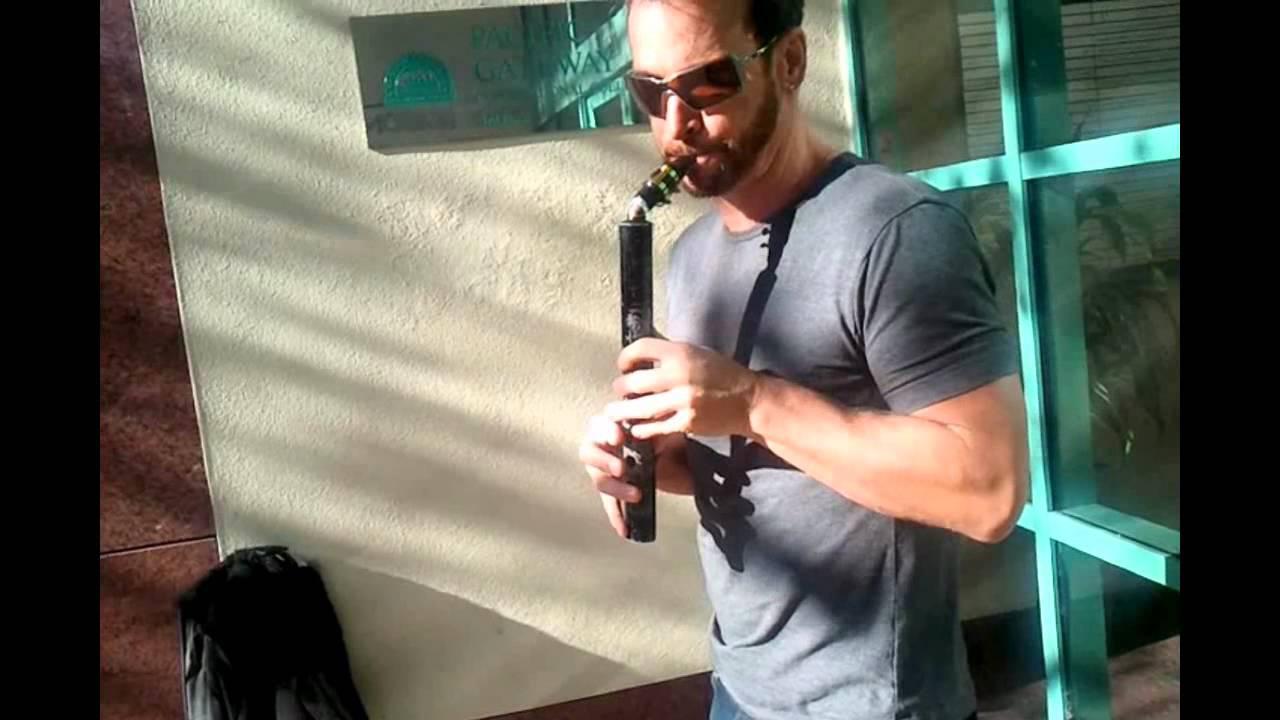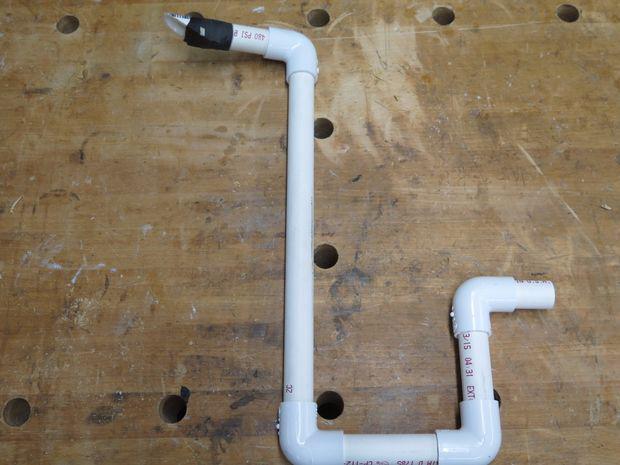The first image is the image on the left, the second image is the image on the right. Given the left and right images, does the statement "Two people can be seen holding a musical instrument." hold true? Answer yes or no. No. The first image is the image on the left, the second image is the image on the right. Analyze the images presented: Is the assertion "Someone is playing an instrument." valid? Answer yes or no. Yes. 